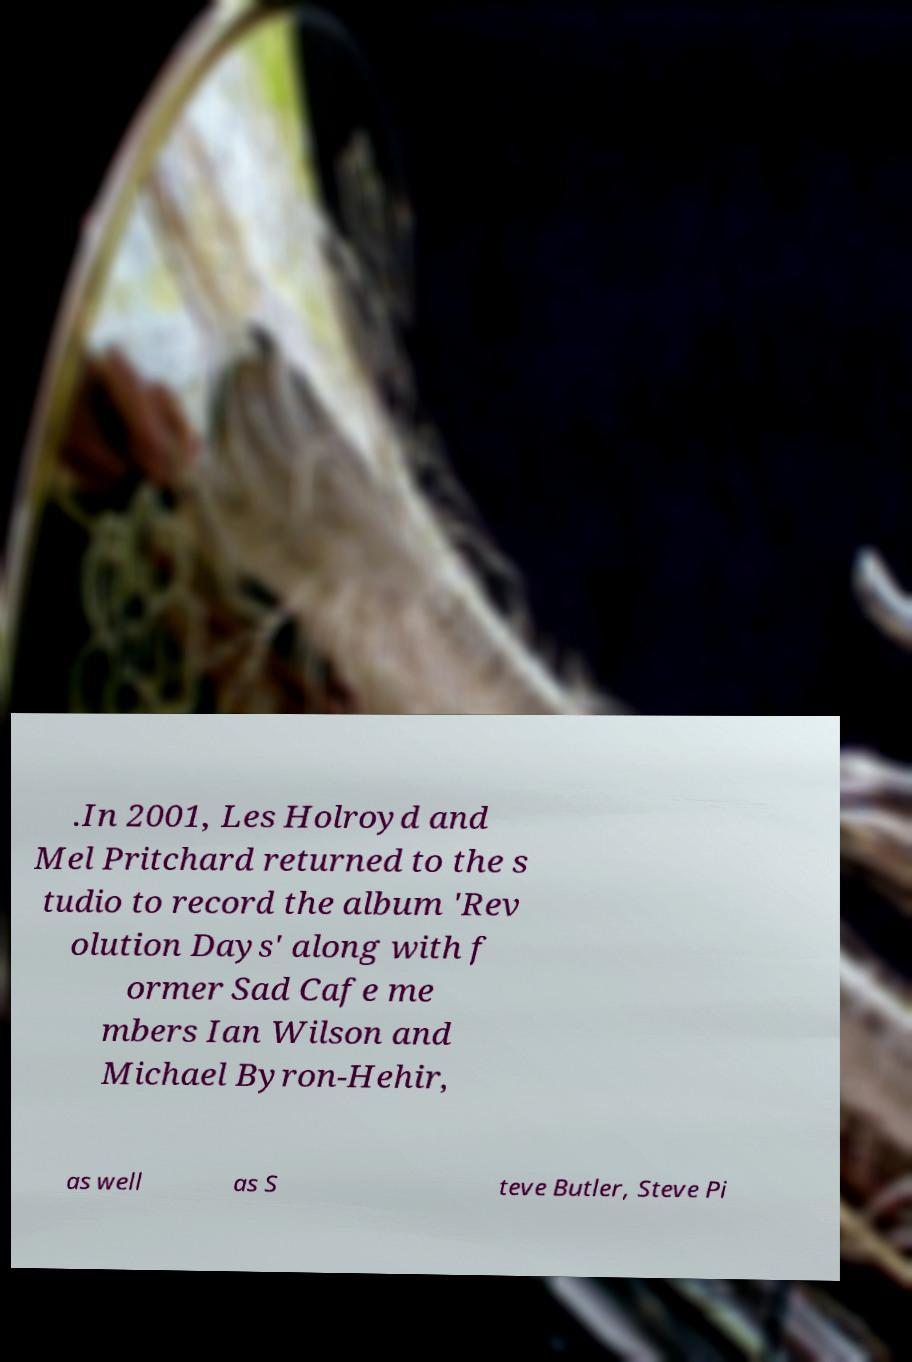Can you read and provide the text displayed in the image?This photo seems to have some interesting text. Can you extract and type it out for me? .In 2001, Les Holroyd and Mel Pritchard returned to the s tudio to record the album 'Rev olution Days' along with f ormer Sad Cafe me mbers Ian Wilson and Michael Byron-Hehir, as well as S teve Butler, Steve Pi 